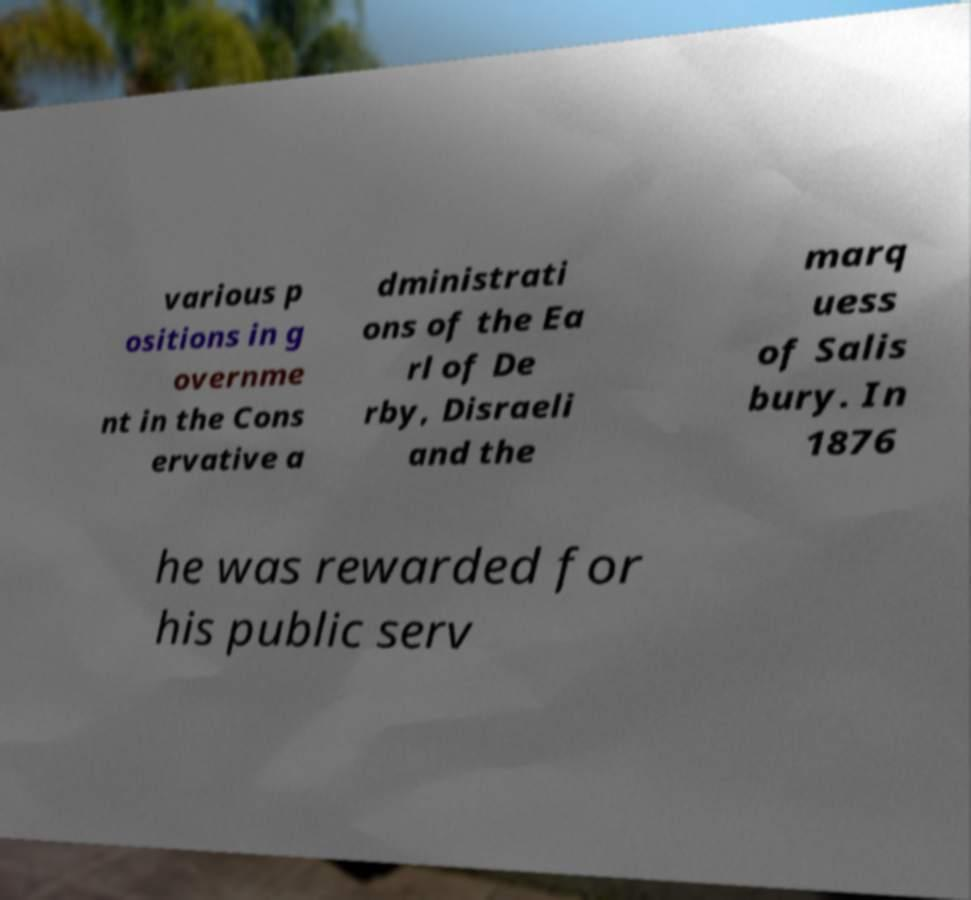There's text embedded in this image that I need extracted. Can you transcribe it verbatim? various p ositions in g overnme nt in the Cons ervative a dministrati ons of the Ea rl of De rby, Disraeli and the marq uess of Salis bury. In 1876 he was rewarded for his public serv 